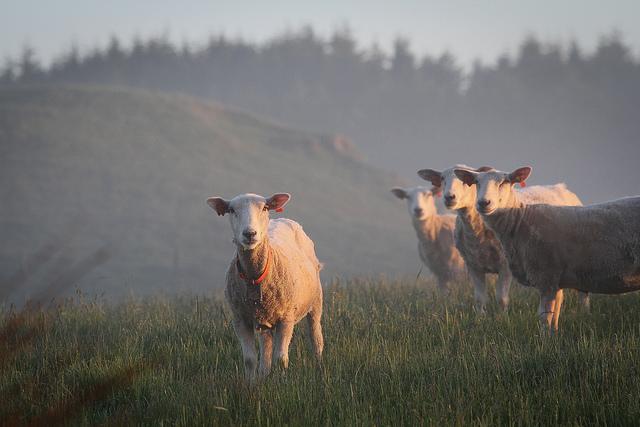Are the sheep headed in the same direction?
Short answer required. Yes. How many animals are in the picture?
Concise answer only. 4. Are the sheep looking in the same direction?
Write a very short answer. Yes. How many horns are on the animals?
Answer briefly. 0. What color is the collar on the first sheep?
Short answer required. Red. 